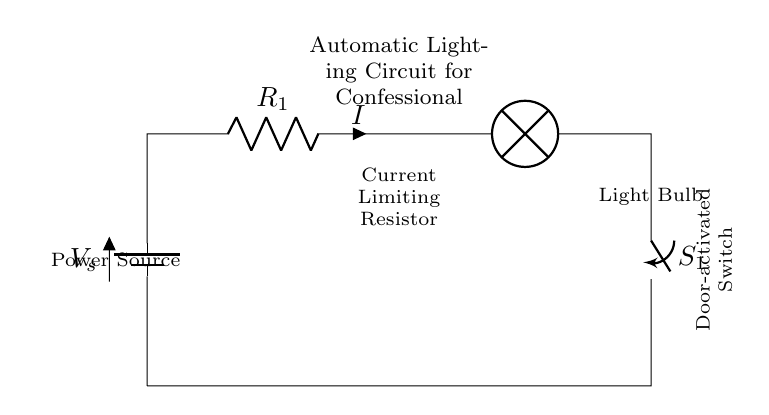What is the function of the battery in this circuit? The battery provides the voltage needed to power the circuit components. It serves as the energy source, ensuring current flows when the circuit is closed.
Answer: Power source What component limits the current in this circuit? The current limiting resistor is specifically designed to restrict the amount of current flowing through the circuit, protecting the light bulb and other components from excessive current.
Answer: Current Limiting Resistor What is activated by the door? The door activates a switch, which is responsible for closing the circuit and allowing current to flow to the light bulb when the door is opened.
Answer: Switch What is the output of the circuit? The output of the circuit is the light produced by the light bulb, which illuminates the confessional booth when the circuit is closed.
Answer: Light Bulb If the switch is open, what happens to the lamp? If the switch is open, the circuit is incomplete, preventing current from flowing, and thus the lamp will not light up.
Answer: Lamp is off How many components are in the circuit? The circuit consists of four components: a battery, a resistor, a light bulb, and a switch.
Answer: Four components What type of circuit is this? This is a series circuit, where all components are connected in a single loop, causing the current to flow through each component sequentially.
Answer: Series Circuit 